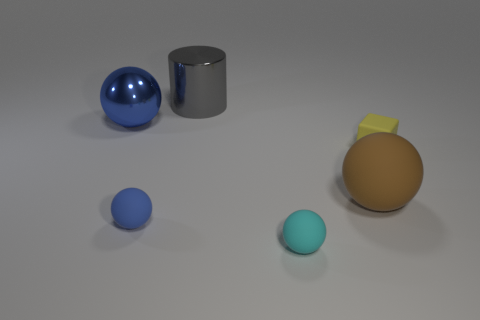Subtract all blue cylinders. How many blue balls are left? 2 Subtract all cyan spheres. How many spheres are left? 3 Add 3 large gray cylinders. How many objects exist? 9 Subtract all cyan spheres. How many spheres are left? 3 Subtract 1 balls. How many balls are left? 3 Subtract all spheres. How many objects are left? 2 Subtract all gray cylinders. Subtract all red matte things. How many objects are left? 5 Add 4 big matte things. How many big matte things are left? 5 Add 1 brown cylinders. How many brown cylinders exist? 1 Subtract 0 brown cylinders. How many objects are left? 6 